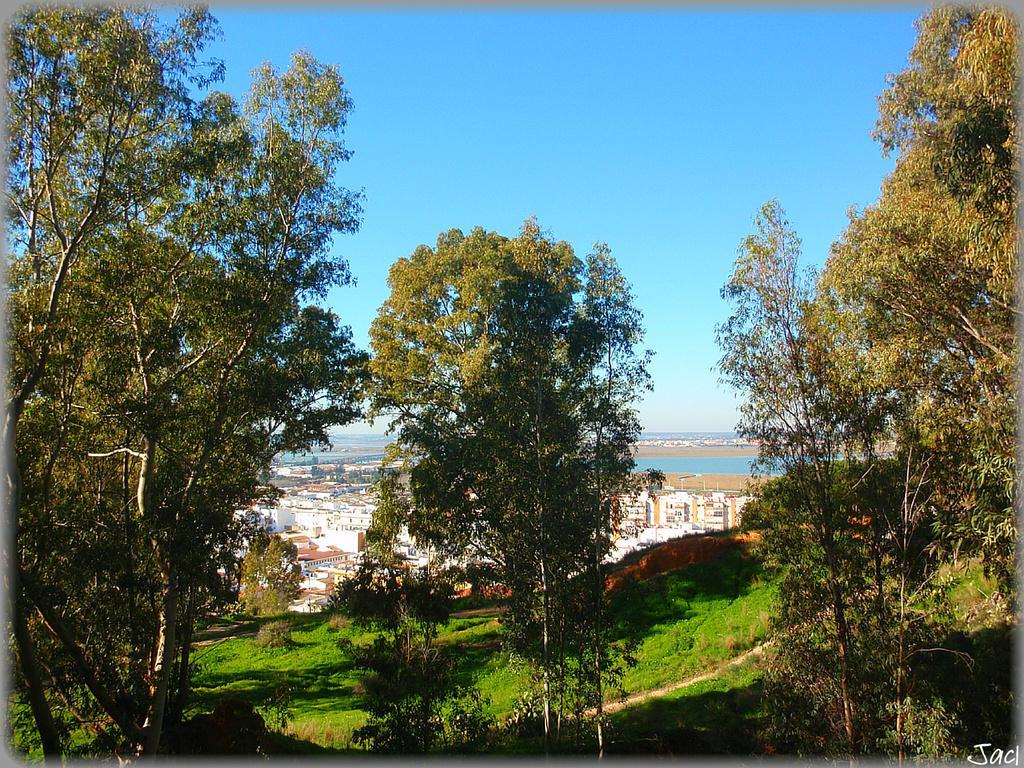Can you describe this image briefly? In the foreground of the picture there are trees, plants and grass. In the center of the picture we can see buildings and water body, it is an aerial view of a city. At the top it is sky. 